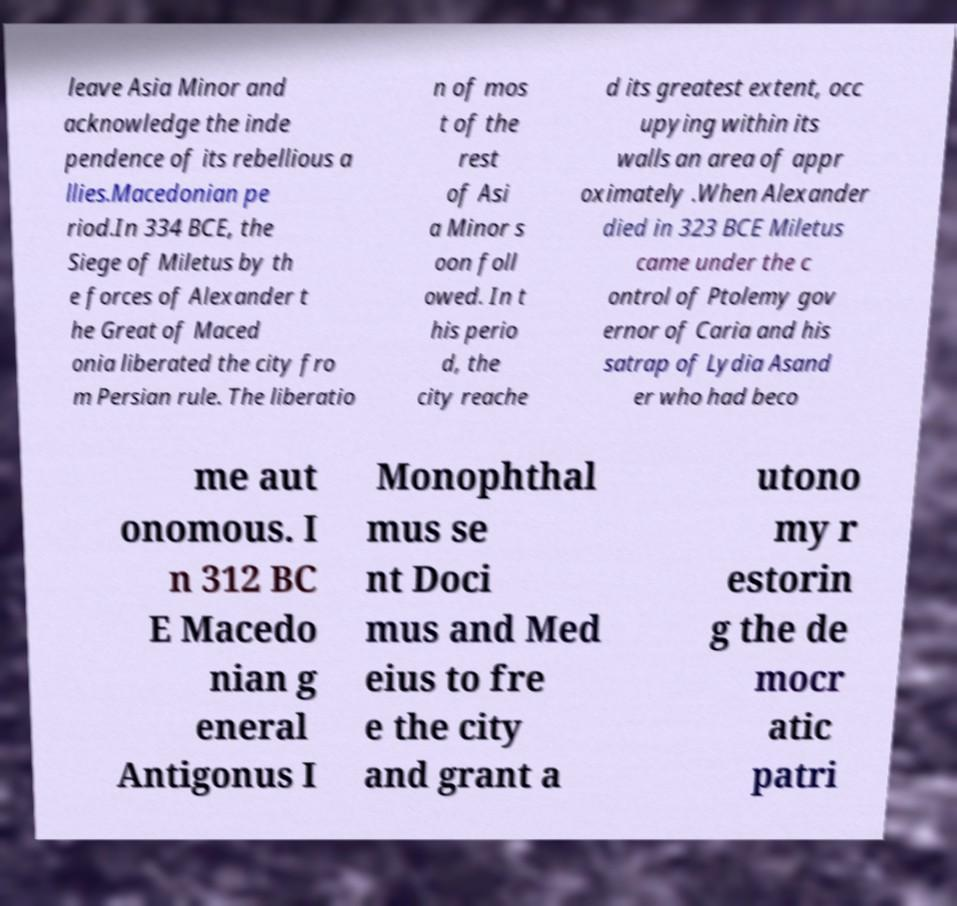For documentation purposes, I need the text within this image transcribed. Could you provide that? leave Asia Minor and acknowledge the inde pendence of its rebellious a llies.Macedonian pe riod.In 334 BCE, the Siege of Miletus by th e forces of Alexander t he Great of Maced onia liberated the city fro m Persian rule. The liberatio n of mos t of the rest of Asi a Minor s oon foll owed. In t his perio d, the city reache d its greatest extent, occ upying within its walls an area of appr oximately .When Alexander died in 323 BCE Miletus came under the c ontrol of Ptolemy gov ernor of Caria and his satrap of Lydia Asand er who had beco me aut onomous. I n 312 BC E Macedo nian g eneral Antigonus I Monophthal mus se nt Doci mus and Med eius to fre e the city and grant a utono my r estorin g the de mocr atic patri 